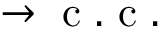<formula> <loc_0><loc_0><loc_500><loc_500>\rightarrow c . c .</formula> 